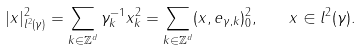Convert formula to latex. <formula><loc_0><loc_0><loc_500><loc_500>| x | _ { l ^ { 2 } ( \gamma ) } ^ { 2 } = \sum _ { k \in \mathbb { Z } ^ { d } } \gamma _ { k } ^ { - 1 } x _ { k } ^ { 2 } = \sum _ { k \in \mathbb { Z } ^ { d } } ( x , e _ { \gamma , k } ) _ { 0 } ^ { 2 } , \quad x \in l ^ { 2 } ( \gamma ) .</formula> 